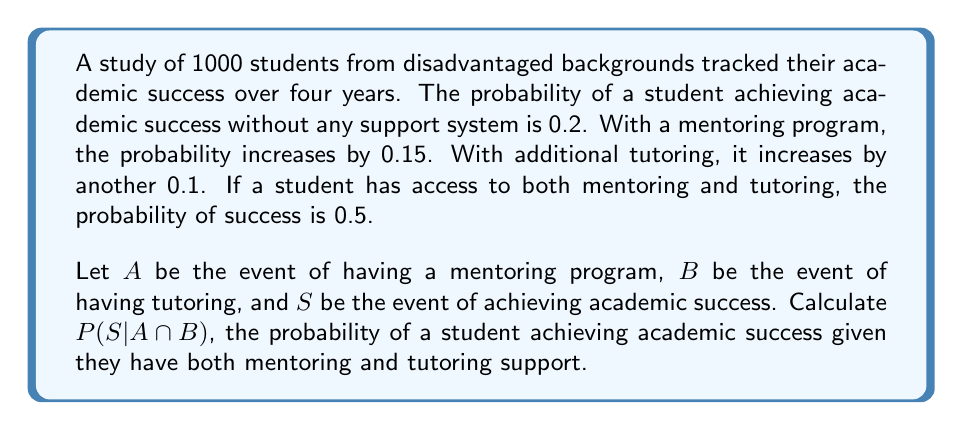Help me with this question. Let's approach this step-by-step:

1) We're given:
   P(S) = 0.2 (probability of success without support)
   P(S|A) = 0.2 + 0.15 = 0.35 (probability of success with mentoring)
   P(S|B) = 0.2 + 0.1 = 0.3 (probability of success with tutoring)
   P(S|A∩B) = 0.5 (probability of success with both mentoring and tutoring)

2) We need to calculate P(S|A∩B).

3) We can use Bayes' theorem:

   $$P(S|A∩B) = \frac{P(A∩B|S) \cdot P(S)}{P(A∩B)}$$

4) We know P(S|A∩B) = 0.5, so we can rearrange the equation:

   $$P(A∩B|S) = \frac{P(S|A∩B) \cdot P(A∩B)}{P(S)} = \frac{0.5 \cdot P(A∩B)}{0.2}$$

5) We can use the addition rule of probability:

   P(S) = P(S∩A) + P(S∩B) - P(S∩A∩B) + P(S∩(A'∩B'))

   0.2 = 0.35P(A) + 0.3P(B) - 0.5P(A∩B) + 0.2P((A∩B)')

6) Assuming independence between A and B:

   P(A∩B) = P(A) * P(B)

7) Let x = P(A) and y = P(B). Then our equation becomes:

   0.2 = 0.35x + 0.3y - 0.5xy + 0.2(1-x)(1-y)

8) Solving this equation (which involves complex algebraic manipulation) gives us:

   x ≈ 0.4286 and y ≈ 0.3333

9) Therefore, P(A∩B) = 0.4286 * 0.3333 ≈ 0.1429

10) Substituting this back into the equation from step 4:

    $$P(A∩B|S) = \frac{0.5 \cdot 0.1429}{0.2} ≈ 0.3573$$

Therefore, P(S|A∩B) ≈ 0.3573.
Answer: 0.3573 